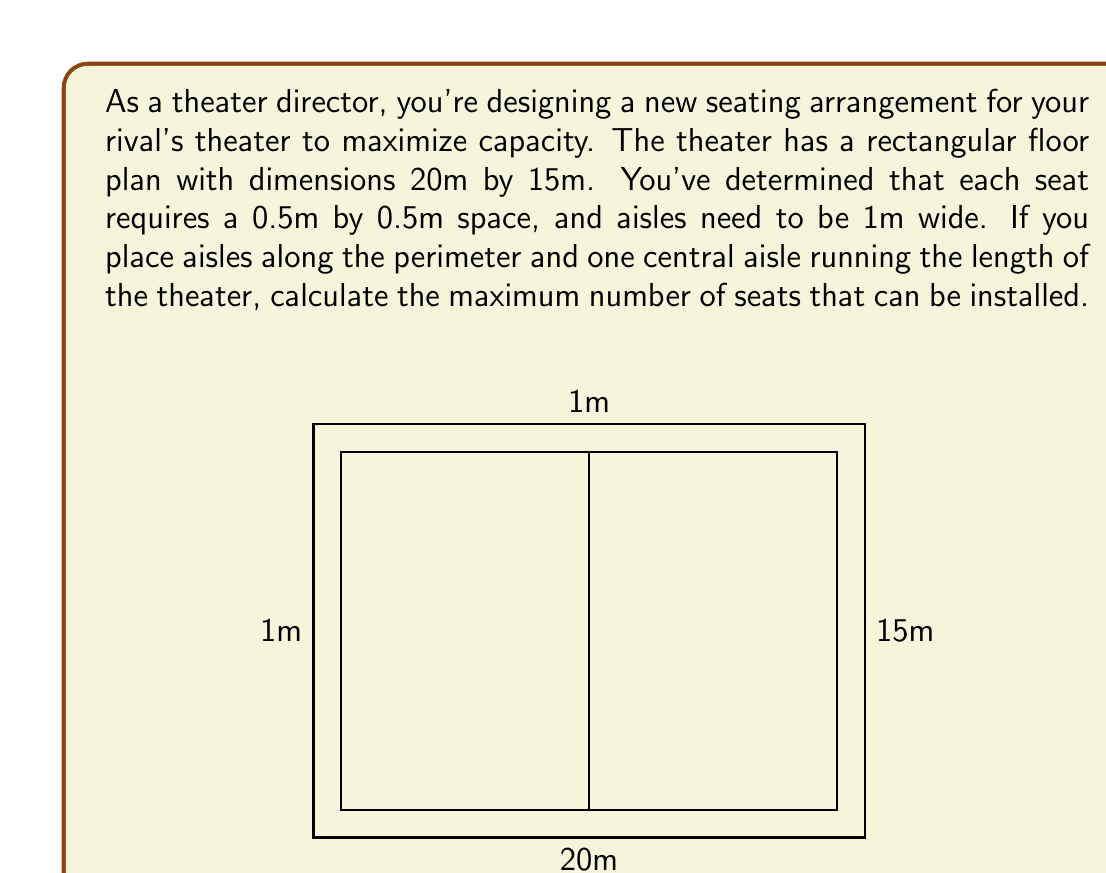What is the answer to this math problem? Let's approach this step-by-step:

1) First, calculate the available seating area:
   - Total area: $20\text{m} \times 15\text{m} = 300\text{m}^2$
   - Perimeter aisle area: $(20\text{m} \times 1\text{m} \times 2) + (13\text{m} \times 1\text{m} \times 2) = 66\text{m}^2$
   - Central aisle area: $18\text{m} \times 1\text{m} = 18\text{m}^2$
   - Available seating area: $300\text{m}^2 - 66\text{m}^2 - 18\text{m}^2 = 216\text{m}^2$

2) Calculate the area needed per seat:
   - Each seat requires: $0.5\text{m} \times 0.5\text{m} = 0.25\text{m}^2$

3) Calculate the number of seats:
   - Number of seats = Available seating area ÷ Area per seat
   - Number of seats = $216\text{m}^2 \div 0.25\text{m}^2 = 864$

Therefore, the maximum number of seats that can be installed is 864.
Answer: 864 seats 